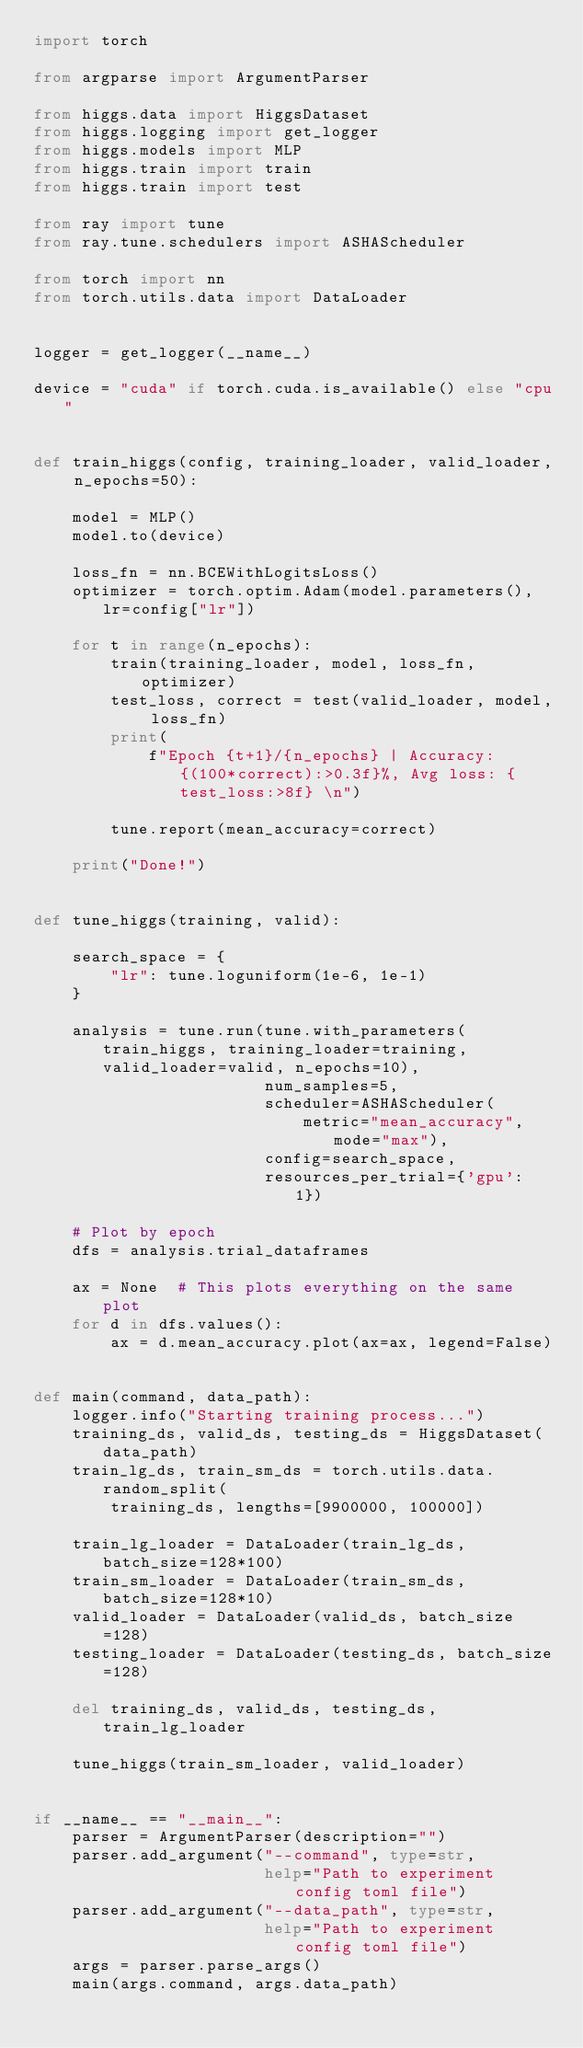<code> <loc_0><loc_0><loc_500><loc_500><_Python_>import torch

from argparse import ArgumentParser

from higgs.data import HiggsDataset
from higgs.logging import get_logger
from higgs.models import MLP
from higgs.train import train
from higgs.train import test

from ray import tune
from ray.tune.schedulers import ASHAScheduler

from torch import nn
from torch.utils.data import DataLoader


logger = get_logger(__name__)

device = "cuda" if torch.cuda.is_available() else "cpu"


def train_higgs(config, training_loader, valid_loader, n_epochs=50):

    model = MLP()
    model.to(device)

    loss_fn = nn.BCEWithLogitsLoss()
    optimizer = torch.optim.Adam(model.parameters(), lr=config["lr"])

    for t in range(n_epochs):
        train(training_loader, model, loss_fn, optimizer)
        test_loss, correct = test(valid_loader, model, loss_fn)
        print(
            f"Epoch {t+1}/{n_epochs} | Accuracy: {(100*correct):>0.3f}%, Avg loss: {test_loss:>8f} \n")

        tune.report(mean_accuracy=correct)

    print("Done!")


def tune_higgs(training, valid):

    search_space = {
        "lr": tune.loguniform(1e-6, 1e-1)
    }

    analysis = tune.run(tune.with_parameters(train_higgs, training_loader=training, valid_loader=valid, n_epochs=10),
                        num_samples=5,
                        scheduler=ASHAScheduler(
                            metric="mean_accuracy", mode="max"),
                        config=search_space,
                        resources_per_trial={'gpu': 1})

    # Plot by epoch
    dfs = analysis.trial_dataframes

    ax = None  # This plots everything on the same plot
    for d in dfs.values():
        ax = d.mean_accuracy.plot(ax=ax, legend=False)


def main(command, data_path):
    logger.info("Starting training process...")
    training_ds, valid_ds, testing_ds = HiggsDataset(data_path)
    train_lg_ds, train_sm_ds = torch.utils.data.random_split(
        training_ds, lengths=[9900000, 100000])

    train_lg_loader = DataLoader(train_lg_ds, batch_size=128*100)
    train_sm_loader = DataLoader(train_sm_ds, batch_size=128*10)
    valid_loader = DataLoader(valid_ds, batch_size=128)
    testing_loader = DataLoader(testing_ds, batch_size=128)

    del training_ds, valid_ds, testing_ds, train_lg_loader

    tune_higgs(train_sm_loader, valid_loader)


if __name__ == "__main__":
    parser = ArgumentParser(description="")
    parser.add_argument("--command", type=str,
                        help="Path to experiment config toml file")
    parser.add_argument("--data_path", type=str,
                        help="Path to experiment config toml file")
    args = parser.parse_args()
    main(args.command, args.data_path)
</code> 